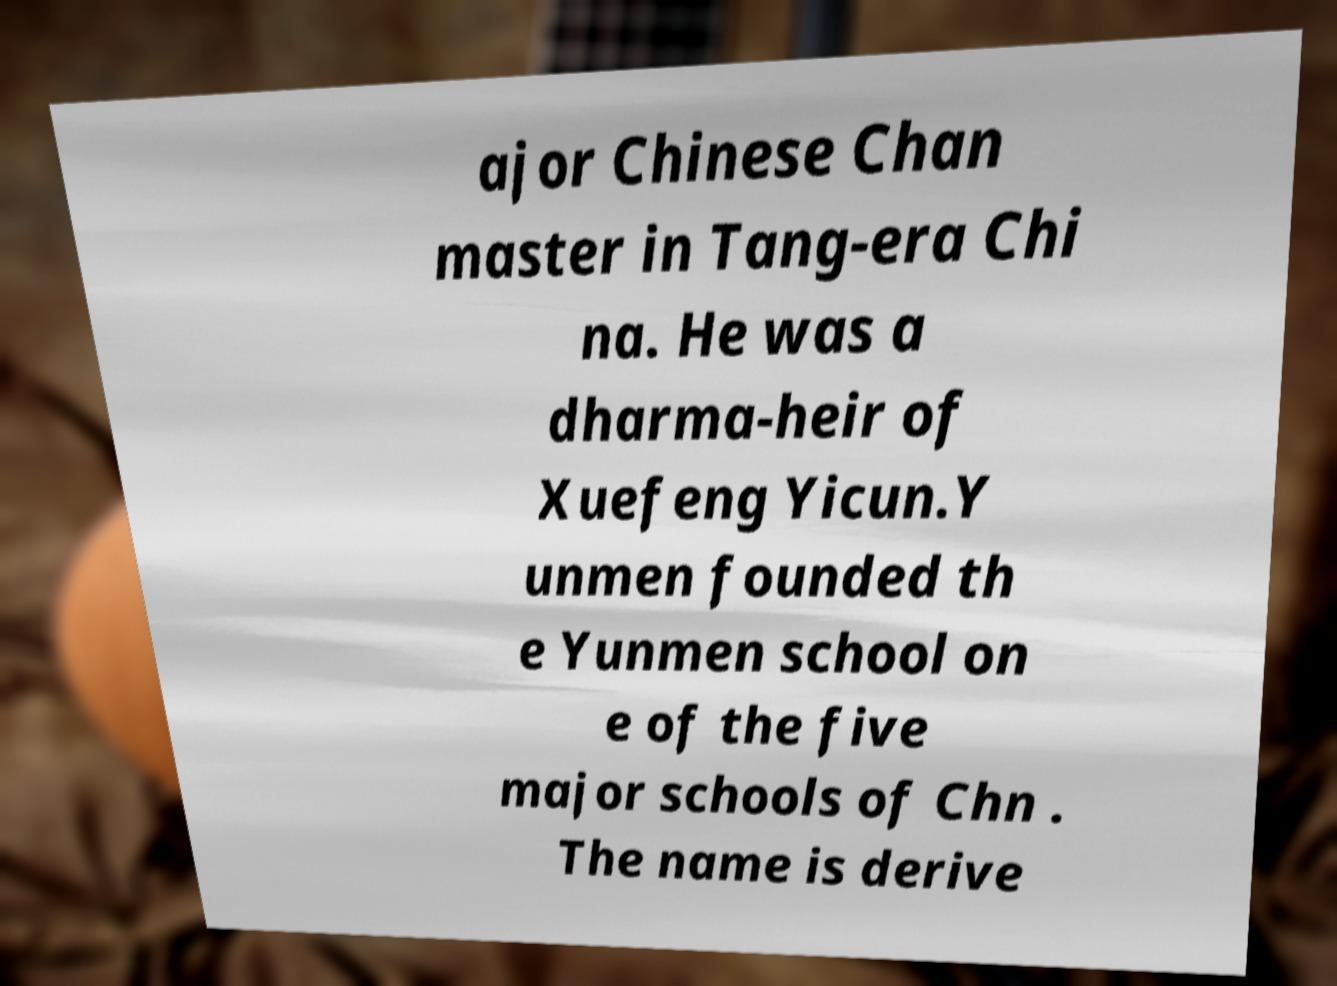Could you extract and type out the text from this image? ajor Chinese Chan master in Tang-era Chi na. He was a dharma-heir of Xuefeng Yicun.Y unmen founded th e Yunmen school on e of the five major schools of Chn . The name is derive 